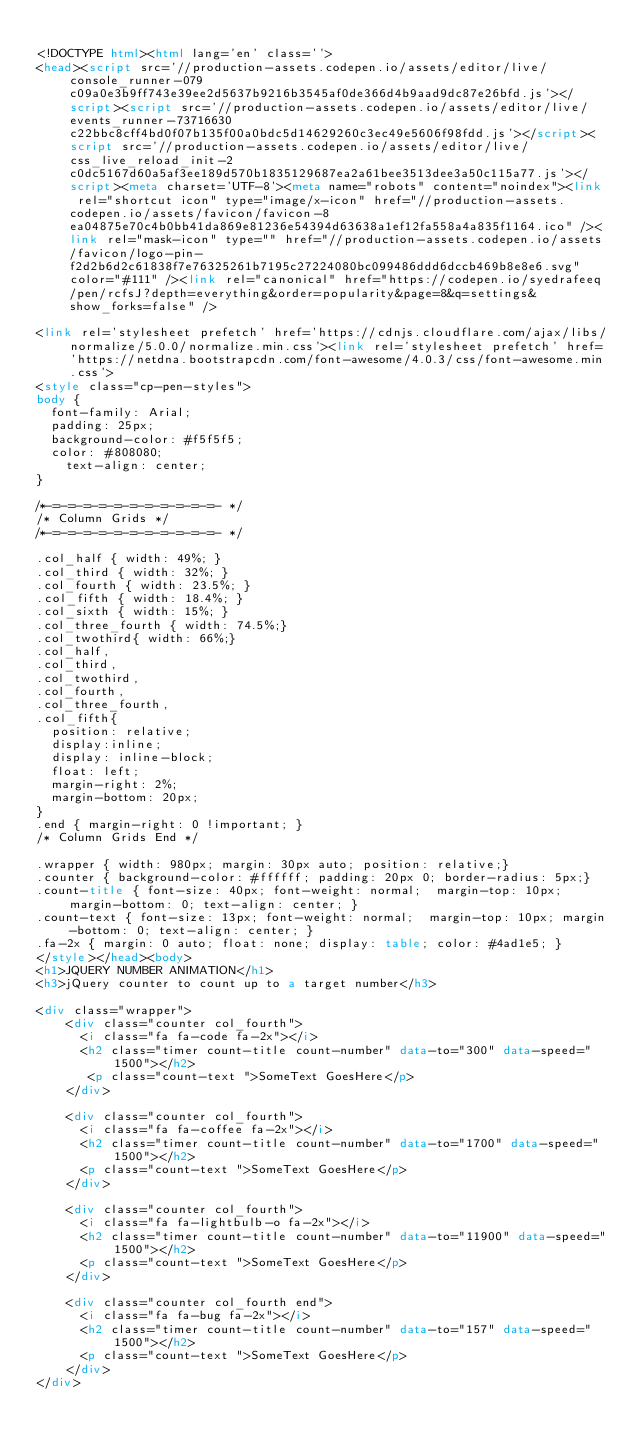Convert code to text. <code><loc_0><loc_0><loc_500><loc_500><_HTML_>
<!DOCTYPE html><html lang='en' class=''>
<head><script src='//production-assets.codepen.io/assets/editor/live/console_runner-079c09a0e3b9ff743e39ee2d5637b9216b3545af0de366d4b9aad9dc87e26bfd.js'></script><script src='//production-assets.codepen.io/assets/editor/live/events_runner-73716630c22bbc8cff4bd0f07b135f00a0bdc5d14629260c3ec49e5606f98fdd.js'></script><script src='//production-assets.codepen.io/assets/editor/live/css_live_reload_init-2c0dc5167d60a5af3ee189d570b1835129687ea2a61bee3513dee3a50c115a77.js'></script><meta charset='UTF-8'><meta name="robots" content="noindex"><link rel="shortcut icon" type="image/x-icon" href="//production-assets.codepen.io/assets/favicon/favicon-8ea04875e70c4b0bb41da869e81236e54394d63638a1ef12fa558a4a835f1164.ico" /><link rel="mask-icon" type="" href="//production-assets.codepen.io/assets/favicon/logo-pin-f2d2b6d2c61838f7e76325261b7195c27224080bc099486ddd6dccb469b8e8e6.svg" color="#111" /><link rel="canonical" href="https://codepen.io/syedrafeeq/pen/rcfsJ?depth=everything&order=popularity&page=8&q=settings&show_forks=false" />

<link rel='stylesheet prefetch' href='https://cdnjs.cloudflare.com/ajax/libs/normalize/5.0.0/normalize.min.css'><link rel='stylesheet prefetch' href='https://netdna.bootstrapcdn.com/font-awesome/4.0.3/css/font-awesome.min.css'>
<style class="cp-pen-styles">
body {
  font-family: Arial;
  padding: 25px;
  background-color: #f5f5f5;
  color: #808080;
  	text-align: center;	
}

/*-=-=-=-=-=-=-=-=-=-=-=- */
/* Column Grids */
/*-=-=-=-=-=-=-=-=-=-=-=- */

.col_half { width: 49%; }
.col_third { width: 32%; }
.col_fourth { width: 23.5%; }
.col_fifth { width: 18.4%; }
.col_sixth { width: 15%; }
.col_three_fourth { width: 74.5%;}
.col_twothird{ width: 66%;}
.col_half,
.col_third,
.col_twothird,
.col_fourth,
.col_three_fourth,
.col_fifth{
	position: relative;
	display:inline;
	display: inline-block;
	float: left;
	margin-right: 2%;
	margin-bottom: 20px;
}
.end { margin-right: 0 !important; }
/* Column Grids End */

.wrapper { width: 980px; margin: 30px auto; position: relative;}
.counter { background-color: #ffffff; padding: 20px 0; border-radius: 5px;}
.count-title { font-size: 40px; font-weight: normal;  margin-top: 10px; margin-bottom: 0; text-align: center; }
.count-text { font-size: 13px; font-weight: normal;  margin-top: 10px; margin-bottom: 0; text-align: center; }
.fa-2x { margin: 0 auto; float: none; display: table; color: #4ad1e5; }
</style></head><body>
<h1>JQUERY NUMBER ANIMATION</h1>
<h3>jQuery counter to count up to a target number</h3>

<div class="wrapper">
    <div class="counter col_fourth">
      <i class="fa fa-code fa-2x"></i>
      <h2 class="timer count-title count-number" data-to="300" data-speed="1500"></h2>
       <p class="count-text ">SomeText GoesHere</p>
    </div>

    <div class="counter col_fourth">
      <i class="fa fa-coffee fa-2x"></i>
      <h2 class="timer count-title count-number" data-to="1700" data-speed="1500"></h2>
      <p class="count-text ">SomeText GoesHere</p>
    </div>

    <div class="counter col_fourth">
      <i class="fa fa-lightbulb-o fa-2x"></i>
      <h2 class="timer count-title count-number" data-to="11900" data-speed="1500"></h2>
      <p class="count-text ">SomeText GoesHere</p>
    </div>

    <div class="counter col_fourth end">
      <i class="fa fa-bug fa-2x"></i>
      <h2 class="timer count-title count-number" data-to="157" data-speed="1500"></h2>
      <p class="count-text ">SomeText GoesHere</p>
    </div>
</div></code> 